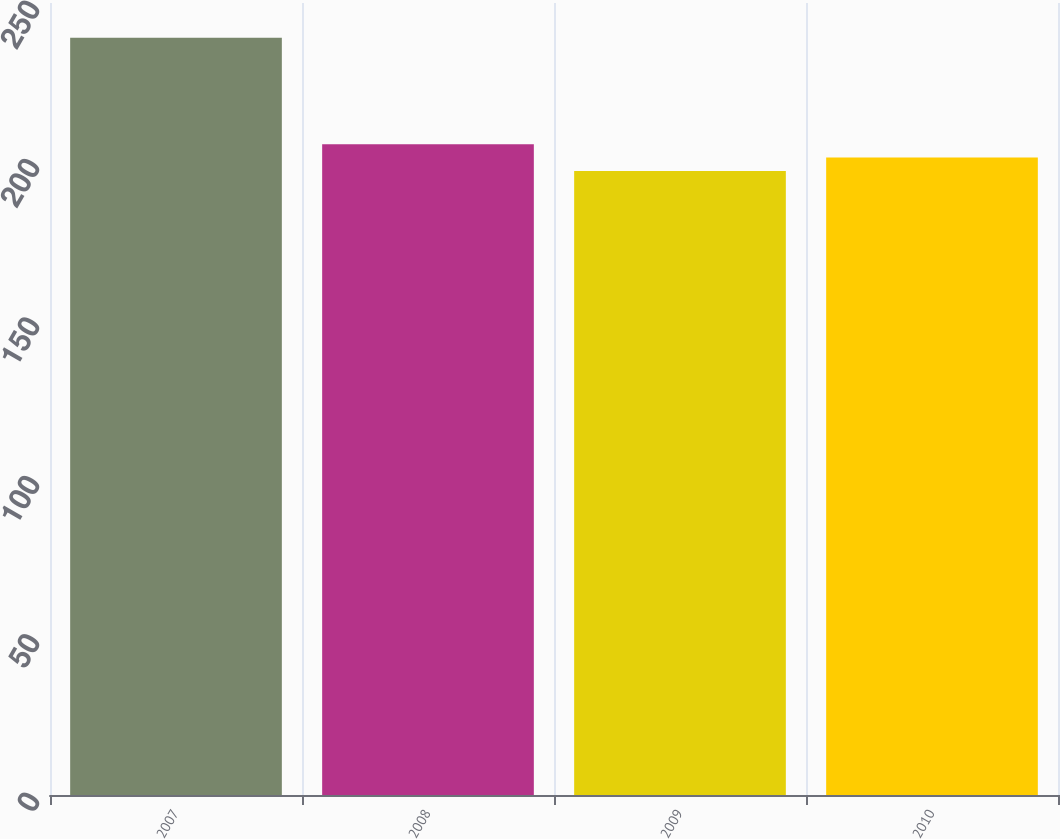<chart> <loc_0><loc_0><loc_500><loc_500><bar_chart><fcel>2007<fcel>2008<fcel>2009<fcel>2010<nl><fcel>239<fcel>205.4<fcel>197<fcel>201.2<nl></chart> 